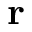<formula> <loc_0><loc_0><loc_500><loc_500>r</formula> 